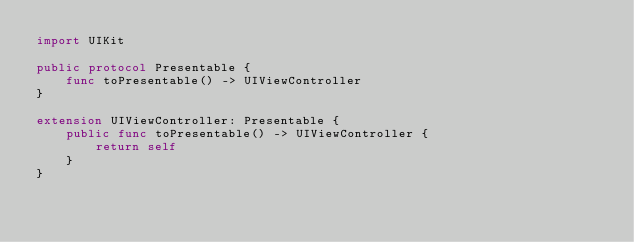<code> <loc_0><loc_0><loc_500><loc_500><_Swift_>import UIKit

public protocol Presentable {
    func toPresentable() -> UIViewController
}

extension UIViewController: Presentable {
    public func toPresentable() -> UIViewController {
        return self
    }
}
</code> 